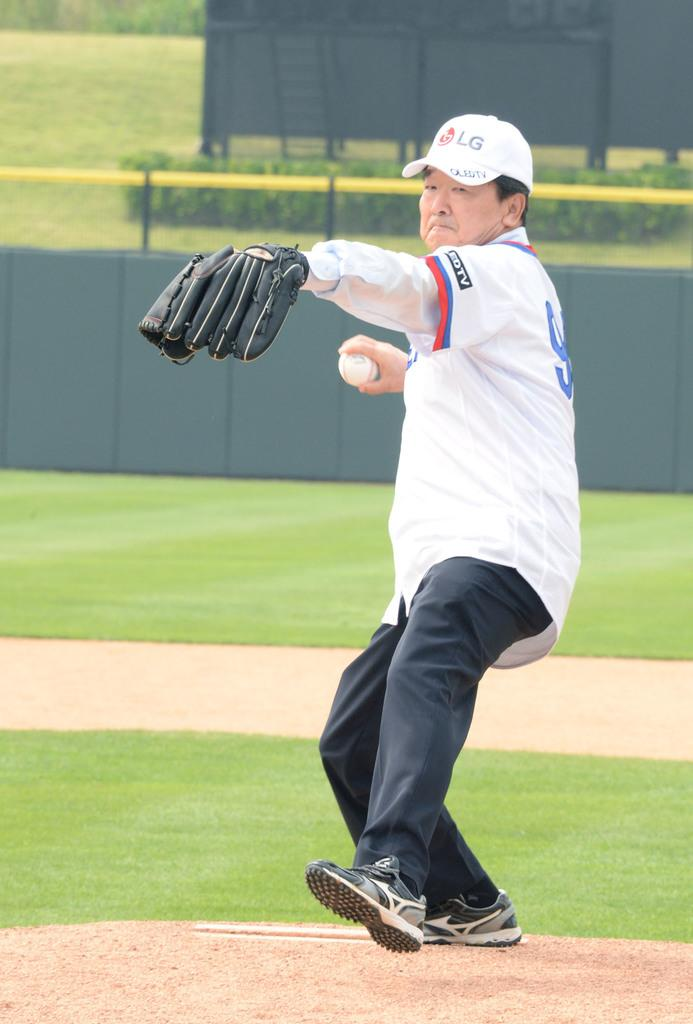<image>
Write a terse but informative summary of the picture. A man pitches a baseball on a mound with an LG hat. 